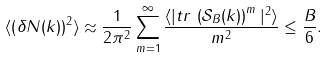<formula> <loc_0><loc_0><loc_500><loc_500>\langle \left ( \delta N ( k ) \right ) ^ { 2 } \rangle \approx \frac { 1 } { 2 \pi ^ { 2 } } \sum _ { m = 1 } ^ { \infty } \frac { \langle | t r \, \left ( \mathcal { S } _ { B } ( k ) \right ) ^ { m } | ^ { 2 } \rangle } { m ^ { 2 } } \leq \frac { B } { 6 } .</formula> 